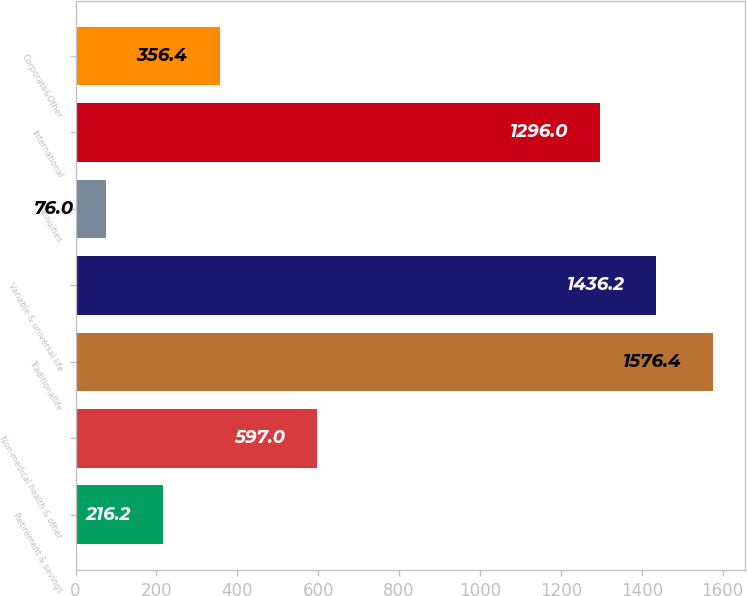Convert chart. <chart><loc_0><loc_0><loc_500><loc_500><bar_chart><fcel>Retirement & savings<fcel>Non-medical health & other<fcel>Traditionallife<fcel>Variable & universal life<fcel>Annuities<fcel>International<fcel>Corporate&Other<nl><fcel>216.2<fcel>597<fcel>1576.4<fcel>1436.2<fcel>76<fcel>1296<fcel>356.4<nl></chart> 